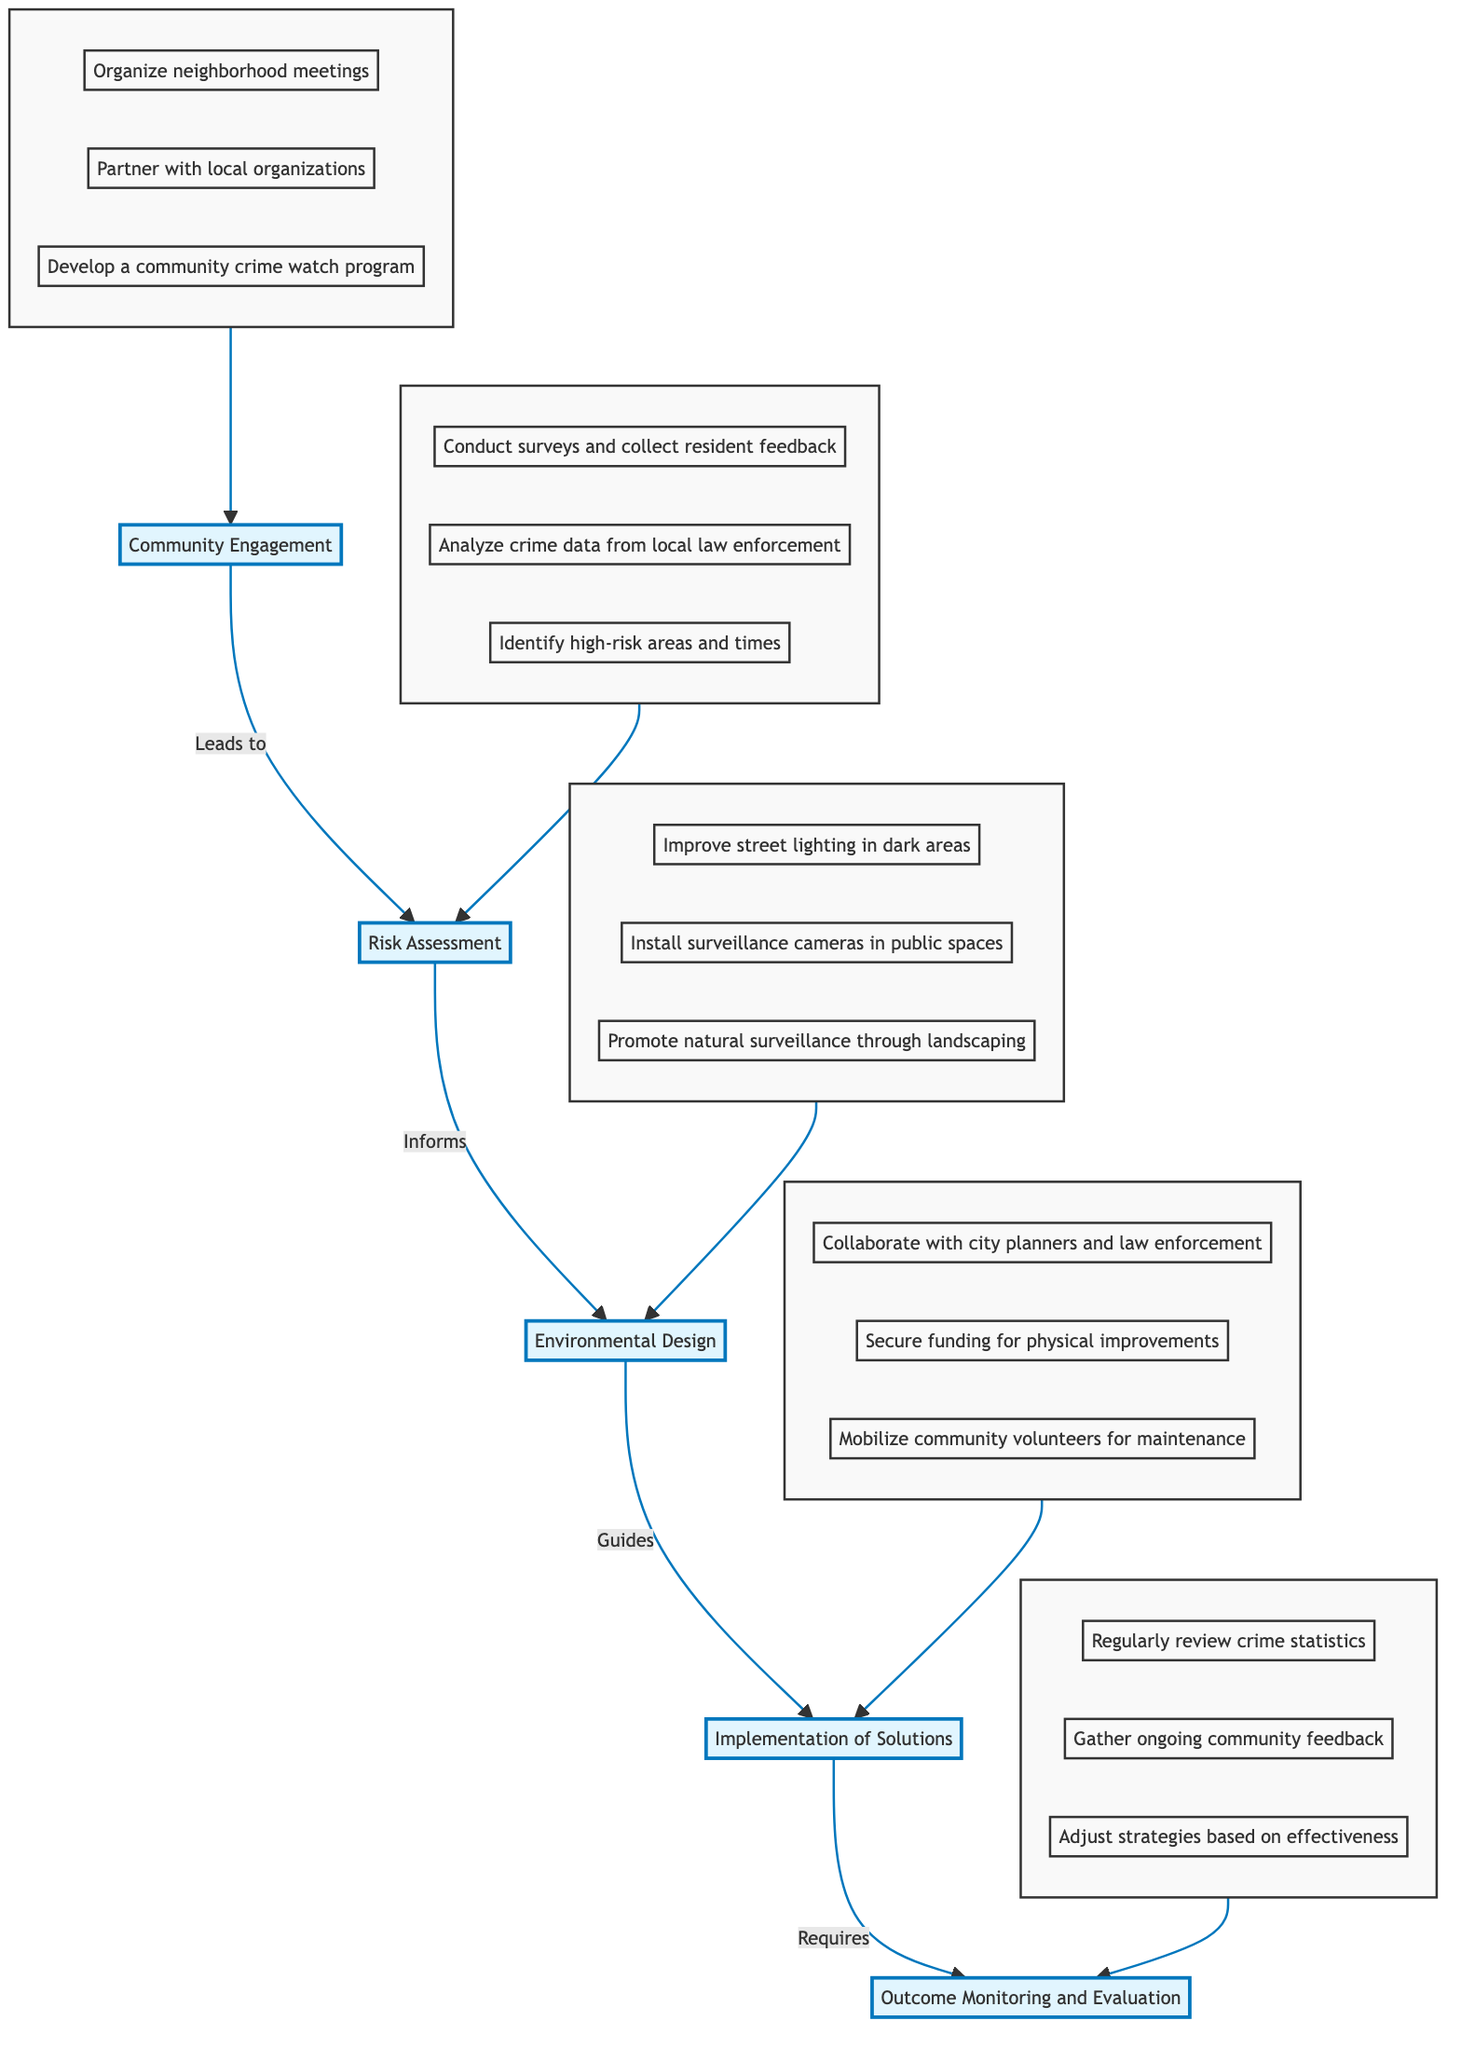What is the highest level node in the diagram? The highest level node in the diagram is "Outcome Monitoring and Evaluation." This node represents the topmost element in the flow structure, indicating it is the final goal of the implemented solutions.
Answer: Outcome Monitoring and Evaluation How many actions are listed under Environmental Design? There are three actions listed under "Environmental Design": Improve street lighting in dark areas, Install surveillance cameras in public spaces, and Promote natural surveillance through strategic landscaping. Counting them gives a total of three actions.
Answer: 3 Which node directly follows Community Engagement? The node that directly follows "Community Engagement" is "Risk Assessment." This is determined by the flow direction in the diagram, indicating that actions of community engagement lead to risks that need to be assessed.
Answer: Risk Assessment What action is related to collaborating with city planners? The action related to collaborating with city planners is "Collaborate with city planners and law enforcement." This is one of the actions listed under the "Implementation of Solutions" node, indicating the necessity of partnership for effective solutions.
Answer: Collaborate with city planners and law enforcement What leads to Implementation of Solutions? The node that leads to "Implementation of Solutions" is "Environmental Design." This shows that information and changes made in the environmental design phase directly influence the actions taken during implementation.
Answer: Environmental Design How many total nodes are there in the diagram? The total number of nodes in the diagram includes five levels: Community Engagement, Risk Assessment, Environmental Design, Implementation of Solutions, and Outcome Monitoring and Evaluation. Thus, there are five nodes in total.
Answer: 5 Which two nodes are connected by the action of "Informs"? The nodes connected by the action "Informs" are "Risk Assessment" and "Environmental Design." This connection indicates that the findings from risk assessments will inform the design changes necessary for crime prevention.
Answer: Risk Assessment and Environmental Design How does community engagement contribute to the overall process? Community engagement contributes by organizing neighborhood meetings, partnering with organizations, and developing a crime watch program. These actions form the foundational step in identifying risks and addressing safety concerns within the community.
Answer: Through foundational actions like organizing meetings and developing crime watches What action is taken at the topmost level of the flow? The action taken at the topmost level of the flow is "Regularly review crime statistics." This action represents the continuous evaluation of crime prevention efforts and their effectiveness.
Answer: Regularly review crime statistics 